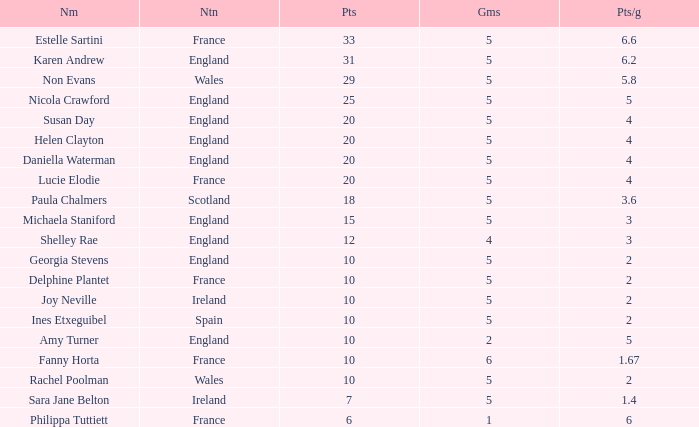Give me the full table as a dictionary. {'header': ['Nm', 'Ntn', 'Pts', 'Gms', 'Pts/g'], 'rows': [['Estelle Sartini', 'France', '33', '5', '6.6'], ['Karen Andrew', 'England', '31', '5', '6.2'], ['Non Evans', 'Wales', '29', '5', '5.8'], ['Nicola Crawford', 'England', '25', '5', '5'], ['Susan Day', 'England', '20', '5', '4'], ['Helen Clayton', 'England', '20', '5', '4'], ['Daniella Waterman', 'England', '20', '5', '4'], ['Lucie Elodie', 'France', '20', '5', '4'], ['Paula Chalmers', 'Scotland', '18', '5', '3.6'], ['Michaela Staniford', 'England', '15', '5', '3'], ['Shelley Rae', 'England', '12', '4', '3'], ['Georgia Stevens', 'England', '10', '5', '2'], ['Delphine Plantet', 'France', '10', '5', '2'], ['Joy Neville', 'Ireland', '10', '5', '2'], ['Ines Etxeguibel', 'Spain', '10', '5', '2'], ['Amy Turner', 'England', '10', '2', '5'], ['Fanny Horta', 'France', '10', '6', '1.67'], ['Rachel Poolman', 'Wales', '10', '5', '2'], ['Sara Jane Belton', 'Ireland', '7', '5', '1.4'], ['Philippa Tuttiett', 'France', '6', '1', '6']]} Can you tell me the lowest Pts/game that has the Games larger than 6? None. 